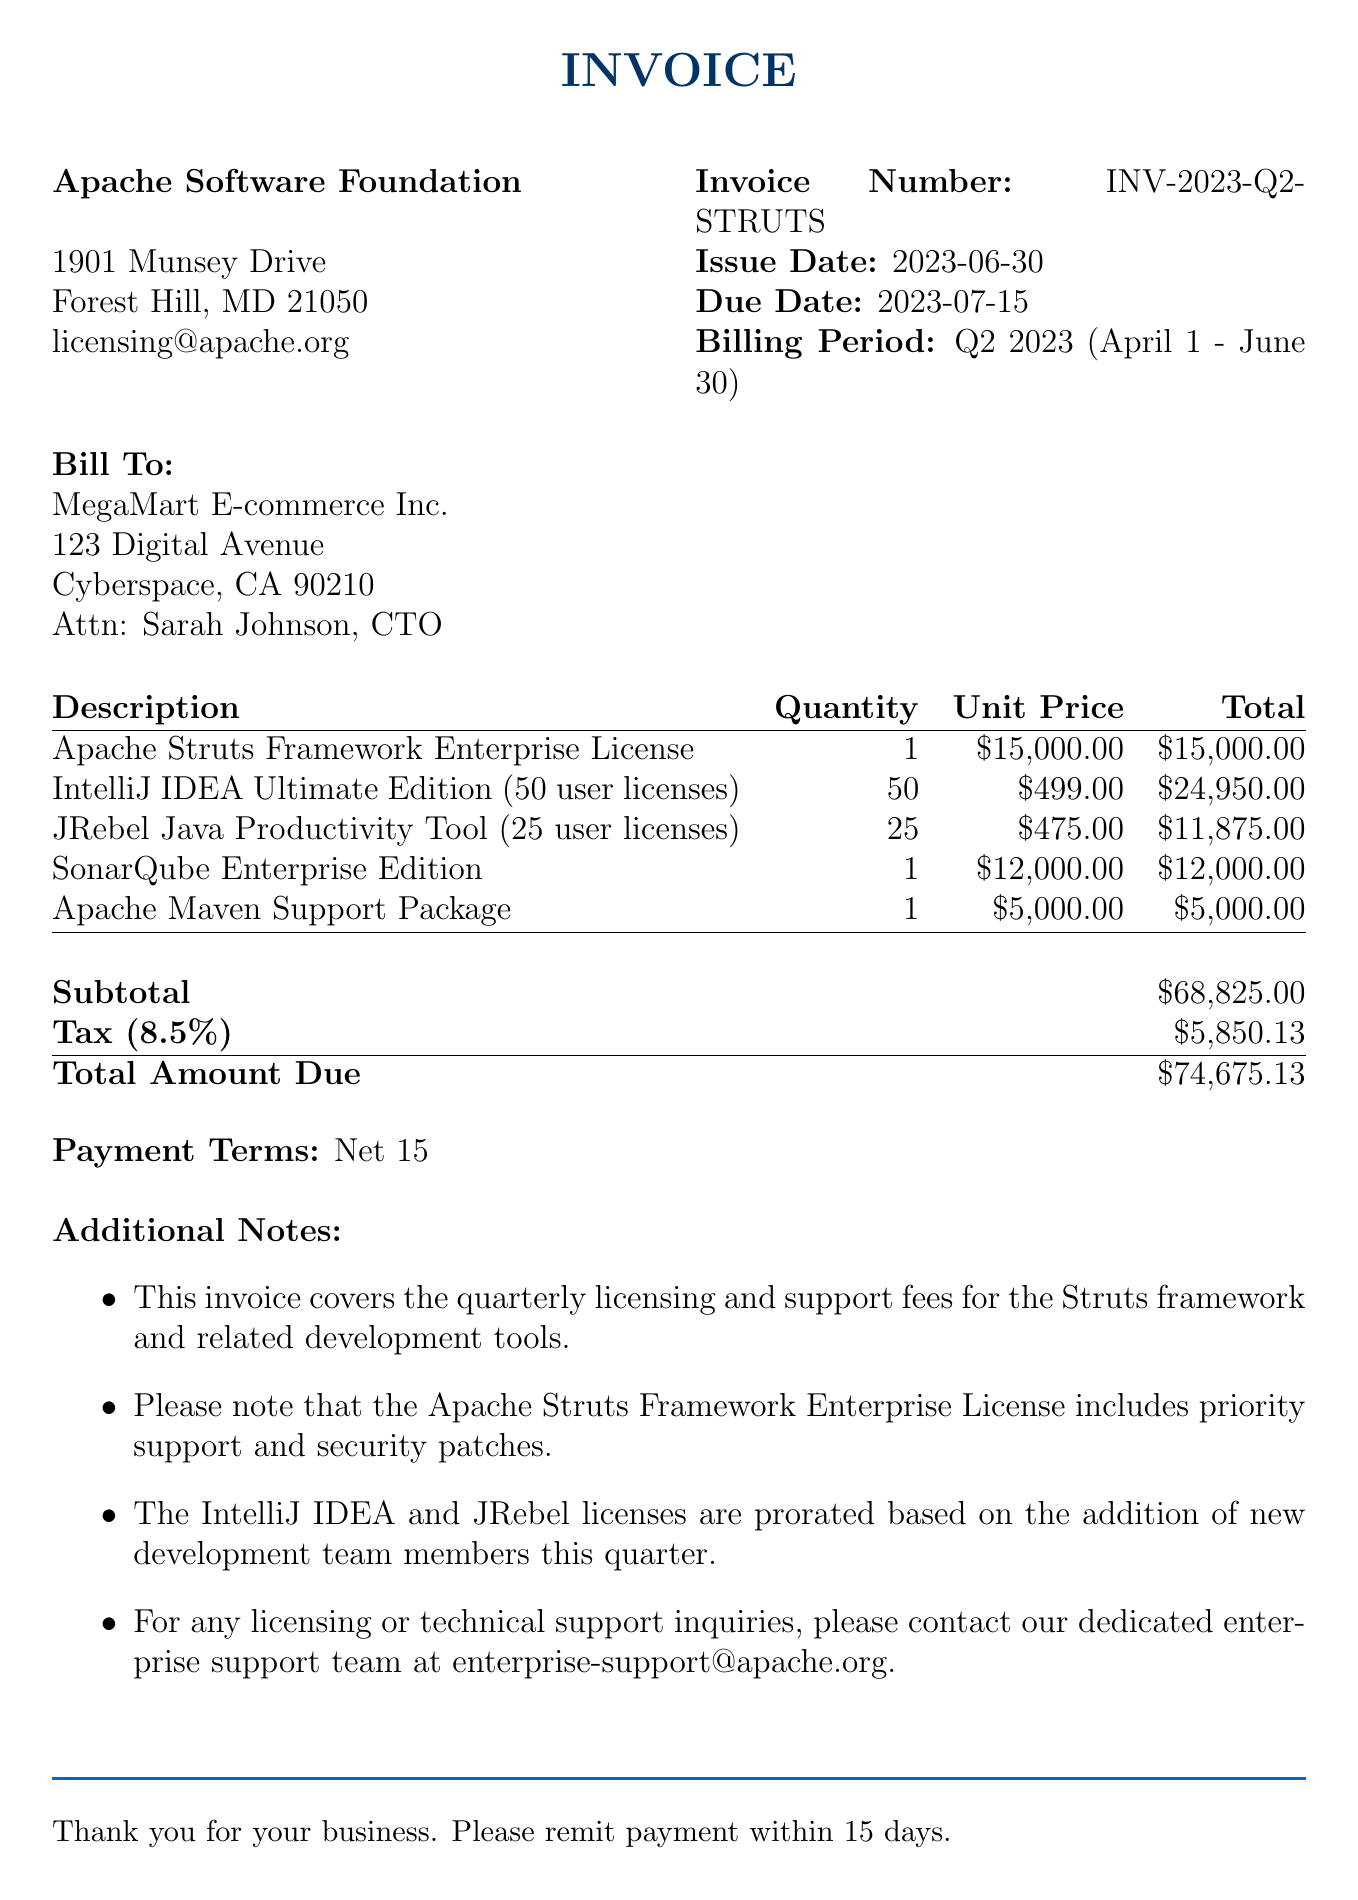What is the invoice number? The invoice number is specified in the document as the unique identifier for this billing instance.
Answer: INV-2023-Q2-STRUTS Who is the contact person for MegaMart E-commerce Inc.? The document lists Sarah Johnson as the contact person for the client company.
Answer: Sarah Johnson What is the total amount due? The total amount due is calculated by adding the subtotal and tax to provide the final billing figure.
Answer: \$74,675.13 What is the issue date of the invoice? The issue date indicates when the invoice was formally issued and is clearly stated in the document.
Answer: 2023-06-30 How many user licenses were purchased for IntelliJ IDEA? The quantity of user licenses for IntelliJ IDEA is a key detail found in the line items of the invoice.
Answer: 50 What is the tax rate applied to this invoice? The tax rate for this invoice, which contributes to the overall amount due, is listed in the calculations provided.
Answer: 8.5% What is the billing period for this invoice? The billing period specifies the time frame covered by the invoice, which is detailed in the document.
Answer: Q2 2023 (April 1 - June 30) What company issued this invoice? The vendor information identifies the company responsible for issuing the invoice.
Answer: Apache Software Foundation What are the payment terms stated in the invoice? The payment terms indicate how soon payment is expected, which is set out clearly in the document.
Answer: Net 15 